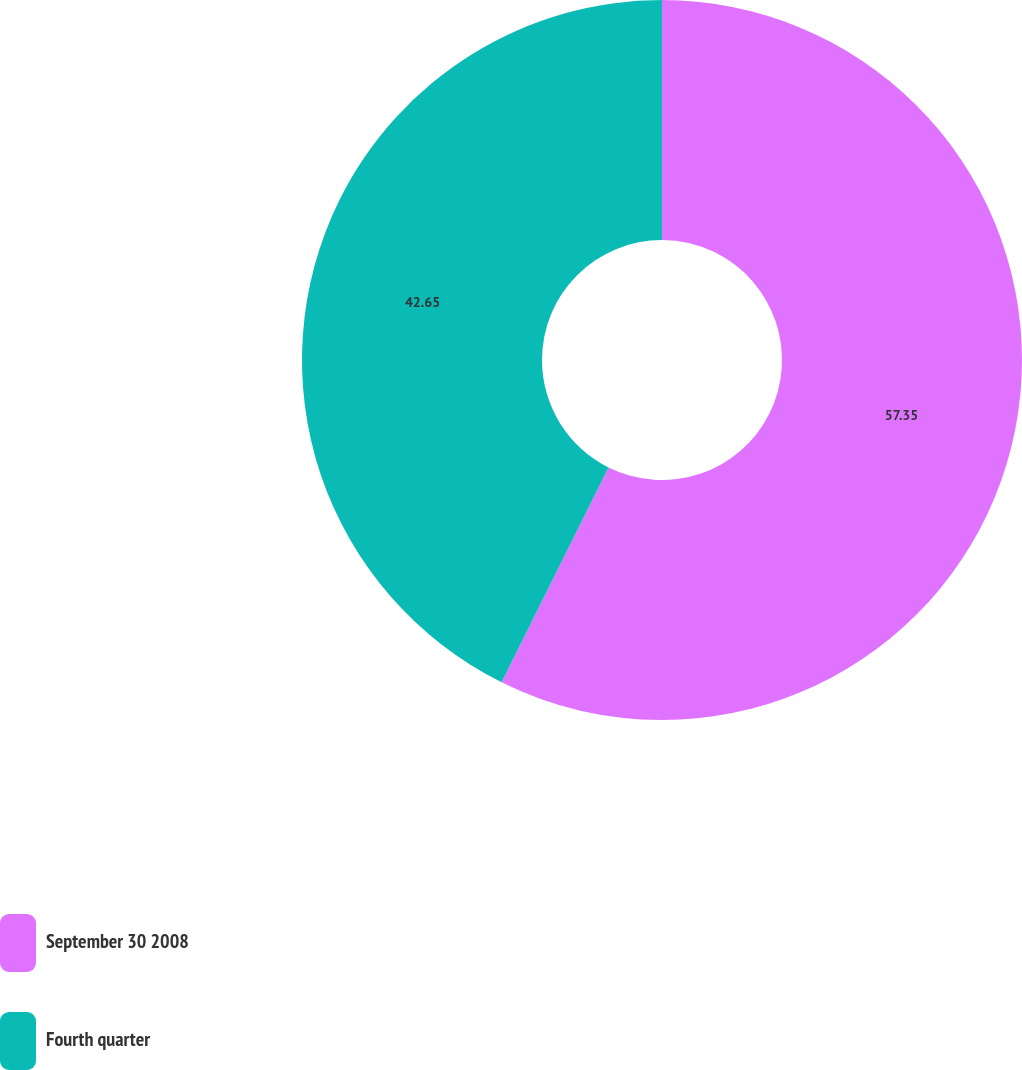Convert chart. <chart><loc_0><loc_0><loc_500><loc_500><pie_chart><fcel>September 30 2008<fcel>Fourth quarter<nl><fcel>57.35%<fcel>42.65%<nl></chart> 